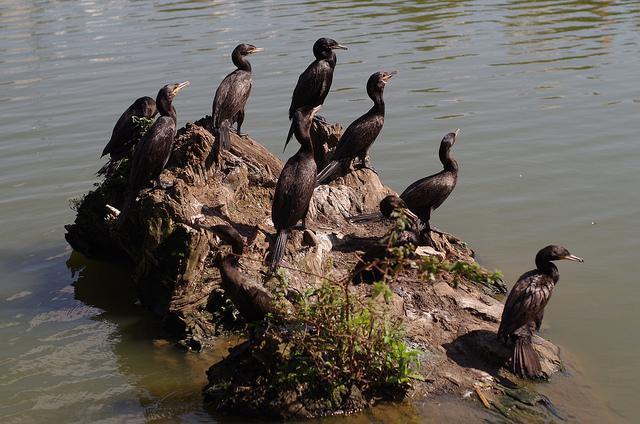How many birds?
Give a very brief answer. 8. How many ducks are here?
Give a very brief answer. 8. How many birds can you see?
Give a very brief answer. 7. 